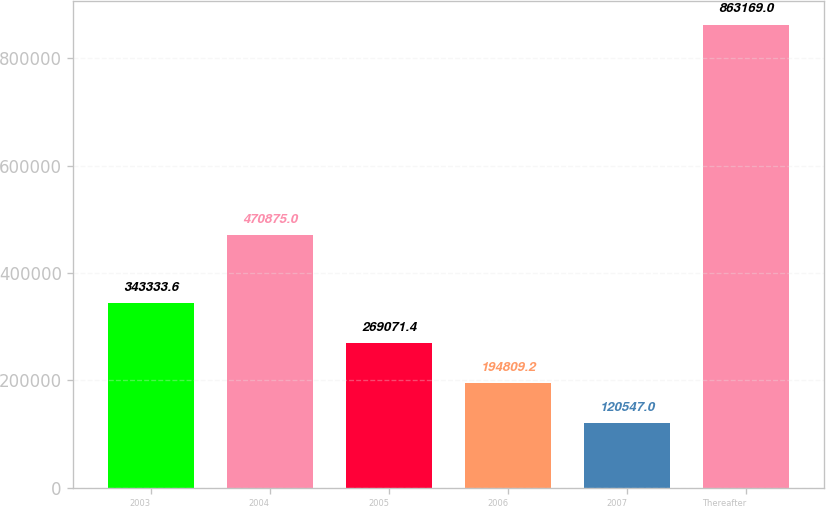<chart> <loc_0><loc_0><loc_500><loc_500><bar_chart><fcel>2003<fcel>2004<fcel>2005<fcel>2006<fcel>2007<fcel>Thereafter<nl><fcel>343334<fcel>470875<fcel>269071<fcel>194809<fcel>120547<fcel>863169<nl></chart> 